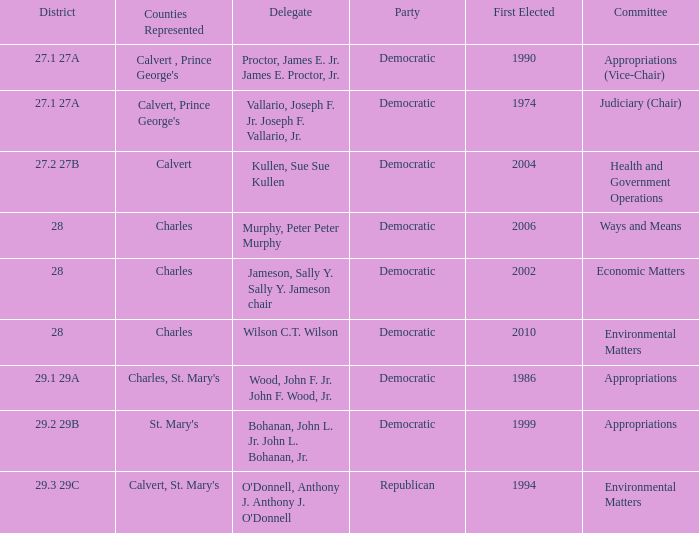Can you parse all the data within this table? {'header': ['District', 'Counties Represented', 'Delegate', 'Party', 'First Elected', 'Committee'], 'rows': [['27.1 27A', "Calvert , Prince George's", 'Proctor, James E. Jr. James E. Proctor, Jr.', 'Democratic', '1990', 'Appropriations (Vice-Chair)'], ['27.1 27A', "Calvert, Prince George's", 'Vallario, Joseph F. Jr. Joseph F. Vallario, Jr.', 'Democratic', '1974', 'Judiciary (Chair)'], ['27.2 27B', 'Calvert', 'Kullen, Sue Sue Kullen', 'Democratic', '2004', 'Health and Government Operations'], ['28', 'Charles', 'Murphy, Peter Peter Murphy', 'Democratic', '2006', 'Ways and Means'], ['28', 'Charles', 'Jameson, Sally Y. Sally Y. Jameson chair', 'Democratic', '2002', 'Economic Matters'], ['28', 'Charles', 'Wilson C.T. Wilson', 'Democratic', '2010', 'Environmental Matters'], ['29.1 29A', "Charles, St. Mary's", 'Wood, John F. Jr. John F. Wood, Jr.', 'Democratic', '1986', 'Appropriations'], ['29.2 29B', "St. Mary's", 'Bohanan, John L. Jr. John L. Bohanan, Jr.', 'Democratic', '1999', 'Appropriations'], ['29.3 29C', "Calvert, St. Mary's", "O'Donnell, Anthony J. Anthony J. O'Donnell", 'Republican', '1994', 'Environmental Matters']]} Which democratic district first experienced an election with a vote count exceeding 2006? 28.0. 